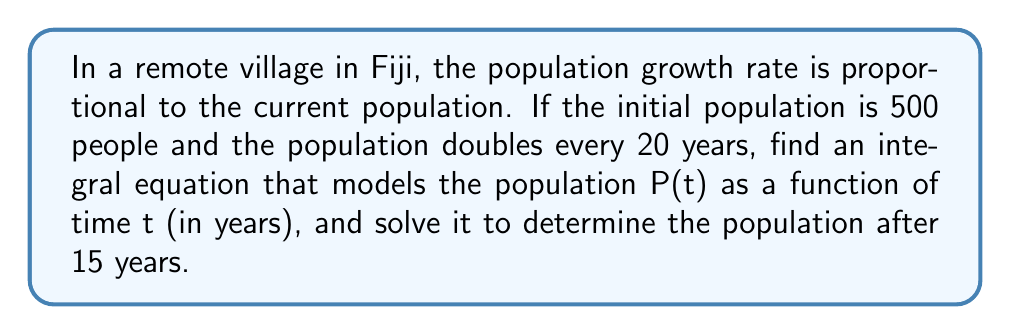Show me your answer to this math problem. 1. Let's start with the differential equation for population growth:
   $$\frac{dP}{dt} = kP$$
   where k is the growth rate constant.

2. To find k, we use the doubling time:
   $$500 \cdot e^{20k} = 1000$$
   $$e^{20k} = 2$$
   $$20k = \ln(2)$$
   $$k = \frac{\ln(2)}{20} \approx 0.0347$$

3. Now, we can write the integral equation:
   $$\int_{500}^{P(t)} \frac{dP}{P} = \int_0^t 0.0347 dt$$

4. Solving the left side:
   $$[\ln(P)]_{500}^{P(t)} = 0.0347t$$

5. Evaluating the limits:
   $$\ln(P(t)) - \ln(500) = 0.0347t$$

6. Simplifying:
   $$\ln\left(\frac{P(t)}{500}\right) = 0.0347t$$

7. Solving for P(t):
   $$P(t) = 500e^{0.0347t}$$

8. To find the population after 15 years, substitute t = 15:
   $$P(15) = 500e^{0.0347 \cdot 15} \approx 817$$

Therefore, after 15 years, the population will be approximately 817 people.
Answer: $P(t) = 500e^{0.0347t}$; 817 people after 15 years 